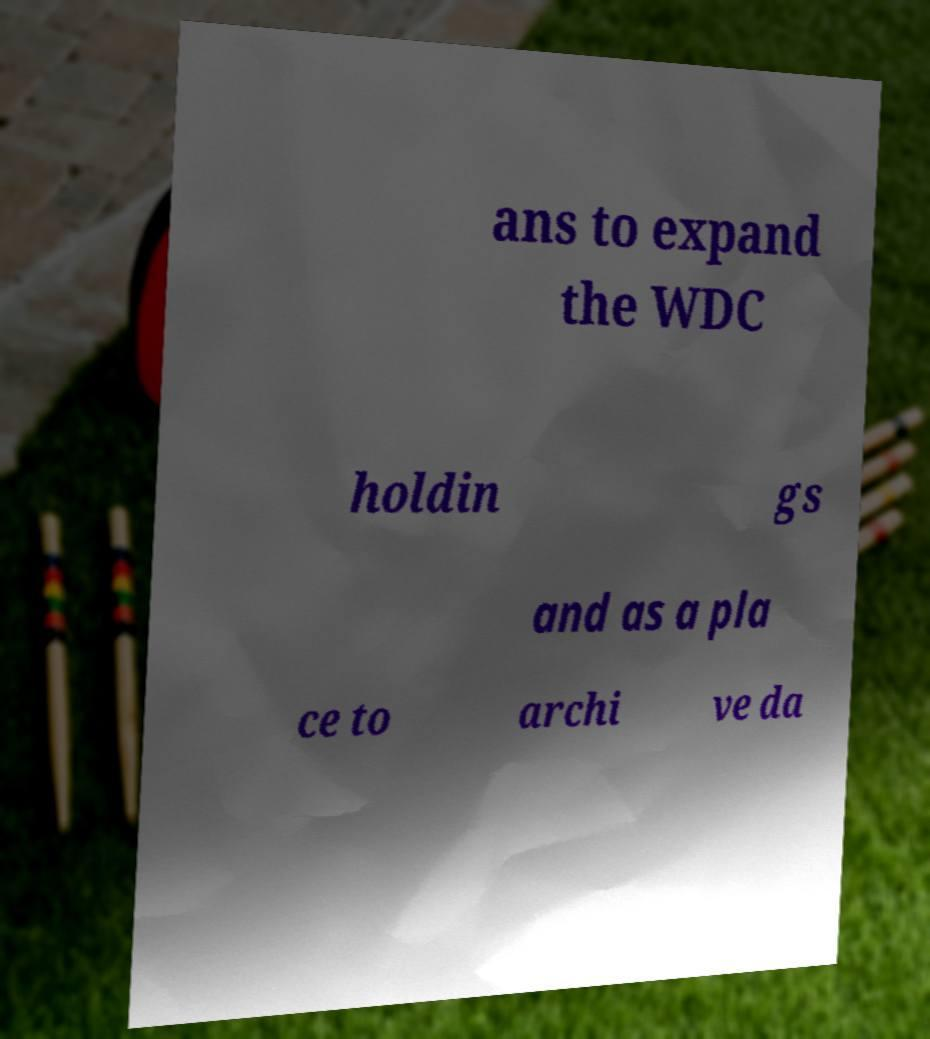I need the written content from this picture converted into text. Can you do that? ans to expand the WDC holdin gs and as a pla ce to archi ve da 